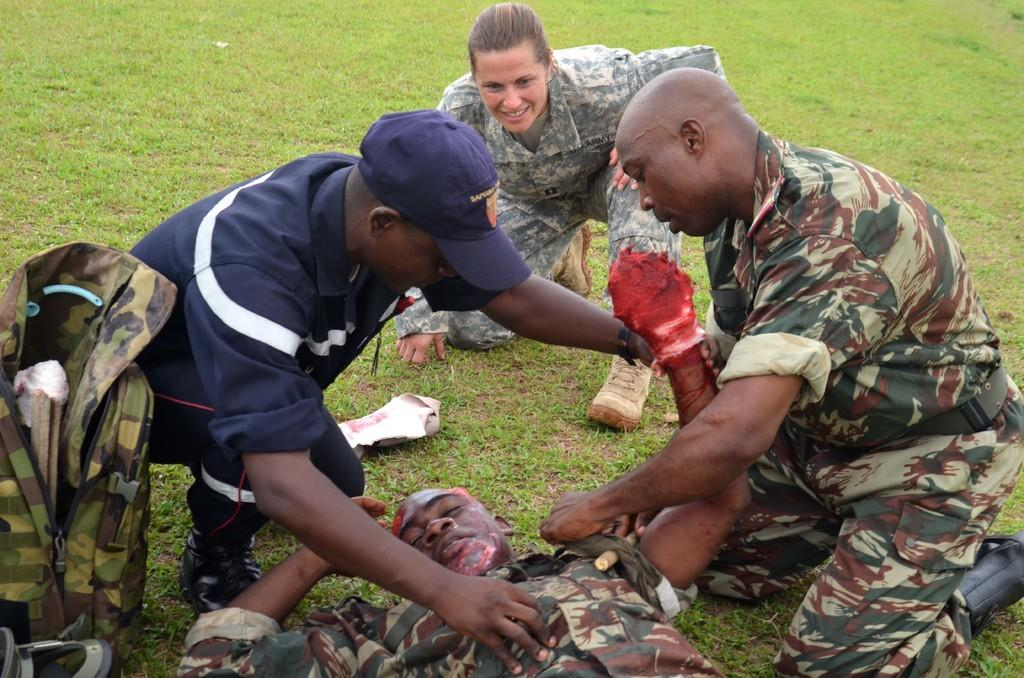What is the main subject of the image? The main subject of the image is a person lying on a grassy land. Where is the grassy land located in the image? The grassy land is at the bottom of the image. How many people are sitting in the image? There are three persons sitting in the middle of the image. What type of toothpaste is the laborer using in the image? There is no laborer or toothpaste present in the image. What is the cause of death for the person lying on the grassy land in the image? There is no indication of death or any cause of death in the image. 